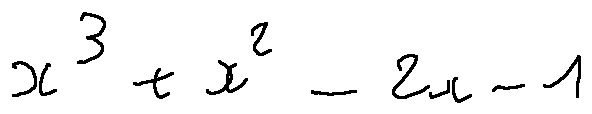Convert formula to latex. <formula><loc_0><loc_0><loc_500><loc_500>x ^ { 3 } + x ^ { 2 } - 2 x - 1</formula> 